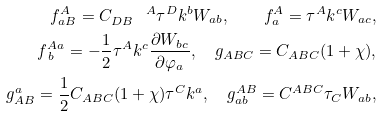Convert formula to latex. <formula><loc_0><loc_0><loc_500><loc_500>f _ { a B } ^ { A } = C _ { D B } ^ { \quad A } \tau ^ { D } k ^ { b } W _ { a b } , \quad f _ { a } ^ { A } = \tau ^ { A } k ^ { c } W _ { a c } , \\ \, f _ { \, b } ^ { A a } = - \frac { 1 } { 2 } \tau ^ { A } k ^ { c } \frac { \partial W _ { b c } } { \partial \varphi _ { a } } , \quad g _ { A B C } = C _ { A B C } ( 1 + \chi ) , \\ g _ { A B } ^ { a } = \frac { 1 } { 2 } C _ { A B C } ( 1 + \chi ) \tau ^ { C } k ^ { a } , \quad g _ { a b } ^ { A B } = C ^ { A B C } \tau _ { C } W _ { a b } ,</formula> 